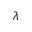<formula> <loc_0><loc_0><loc_500><loc_500>\lambda</formula> 